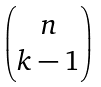Convert formula to latex. <formula><loc_0><loc_0><loc_500><loc_500>\begin{pmatrix} n \\ k - 1 \end{pmatrix}</formula> 